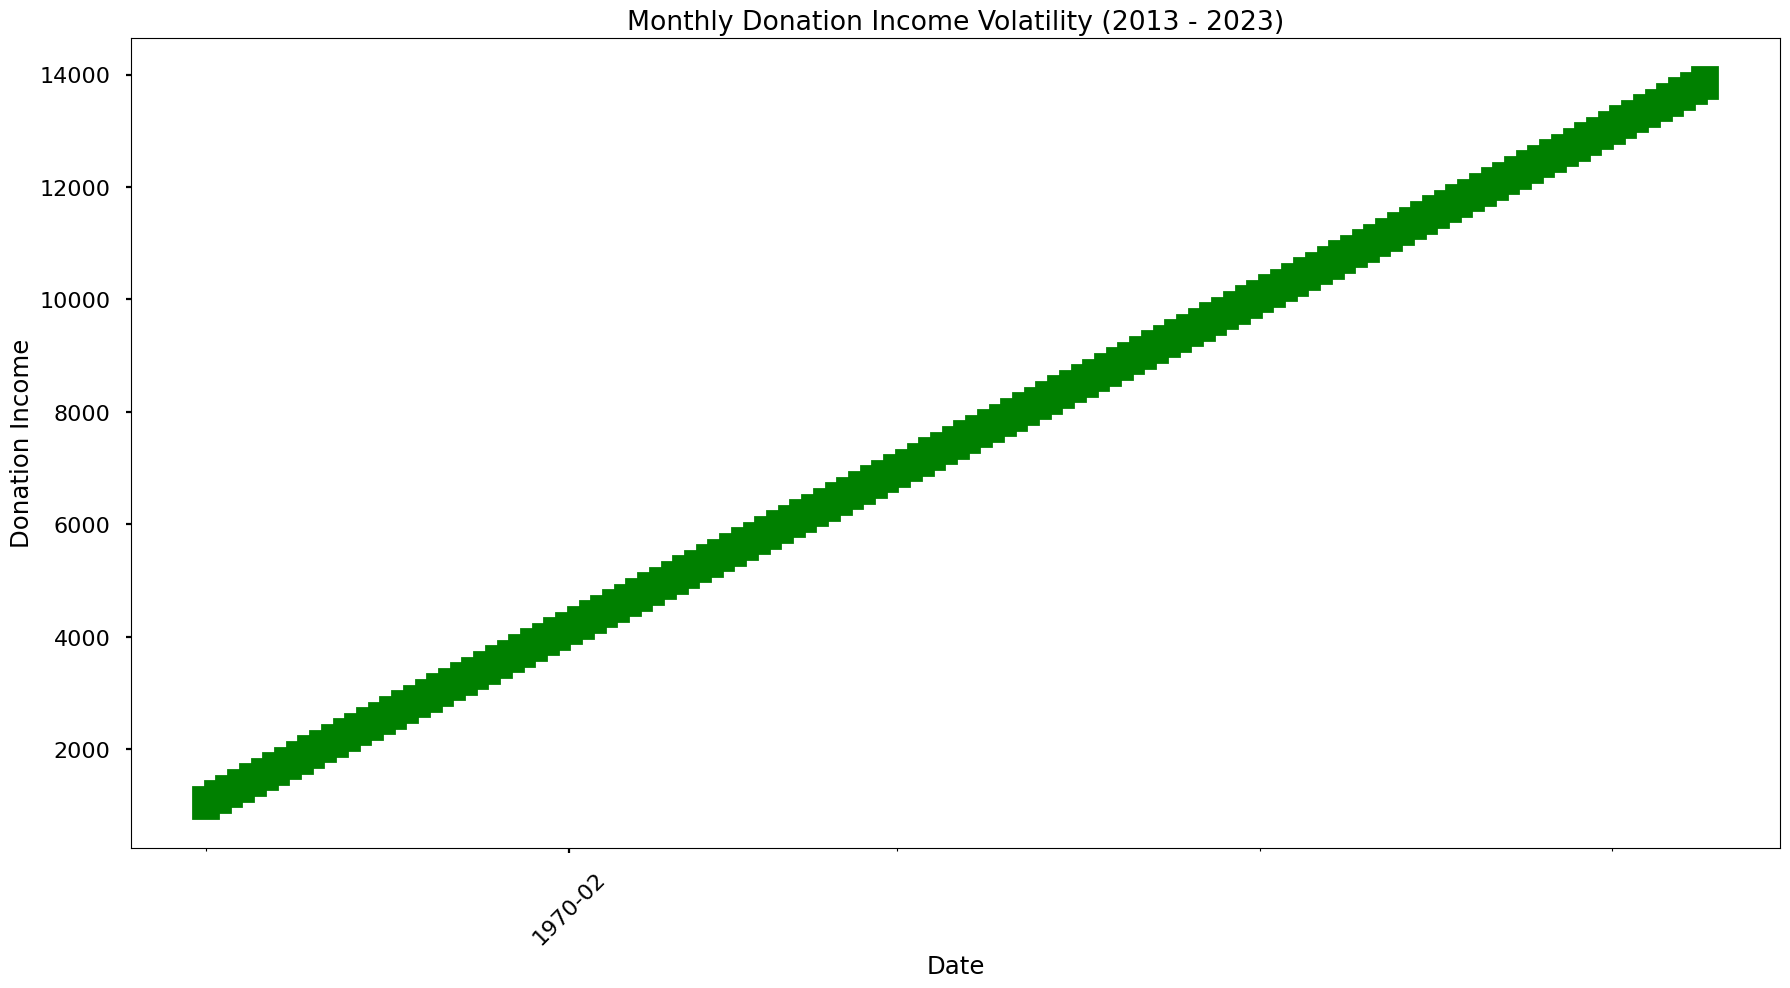What's the highest monthly donation income observed in the past decade? The highest donation income is indicated by the highest point on the high-low lines in the figure. By visual inspection, the highest point occurs in September 2023, marked at 14,000.
Answer: 14,000 Which month and year had the largest drop in donation income from open to close? By examining the candlesticks, the largest drop is indicated by the longest red bar (where the close is less than the open), occurring in January 2013, with an open of 1,000 and a close of 1,100. The largest difference is 200.
Answer: January 2013 During which period did the donation income show the most consistent increase month over month? The most consistent increase is indicated by consecutive green bars (where close is higher than or equal to open) without interruptions. Visual inspection shows an uninterrupted increase from January 2013 to December 2022.
Answer: January 2013 to December 2022 What was the average monthly high donation income in 2019? To calculate the annual average, sum the monthly high donation incomes in 2019 (8,400, 8,500, 8,600, 8,700, 8,800, 8,900, 9,000, 9,100, 9,200, 9,300, 9,400, 9,500) which equals 105,600, then divide by 12. Average = 105,600 / 12 = 8,800.
Answer: 8,800 Between which two consecutive months was the smallest change in the donation income observed? The smallest change between two consecutive months is indicated by the smallest visual difference in close prices. This is found between July 2019 (close of 8,800) and August 2019 (close of 9,000), a difference of 200.
Answer: July 2019 and August 2019 How many months experienced a drop in donation income compared to the previous month over the past decade? Count the number of red candlesticks in the figure, indicating a drop in donation income from open to close. There are no red candlesticks in the entire decade, showing consistent increase.
Answer: 0 What is the total increase in donation income from January 2013 to September 2023? Calculate the difference between donation income in January 2013 (1,000) and September 2023 (13,900). Total increase = 13,900 - 1,000 = 12,900.
Answer: 12,900 Which year saw the highest volatility in monthly donation income? The year with the highest volatility will have the greatest range between the highest high and the lowest low. Checking each year visually, 2023 shows the highest volatility with values ranging from a high of 14,000 in September 2023 to a low of 13,600 in July 2023, a range of 400.
Answer: 2023 What is the median closing donation income for the entire dataset? First, list all closing values, then find the middle value(s). Given 129 months of data (odd), the median is the 65th value: (1,100 + 12,300)/2 = 6,700. By visual inspection, July 2016 is the median closing income.
Answer: 6,700 